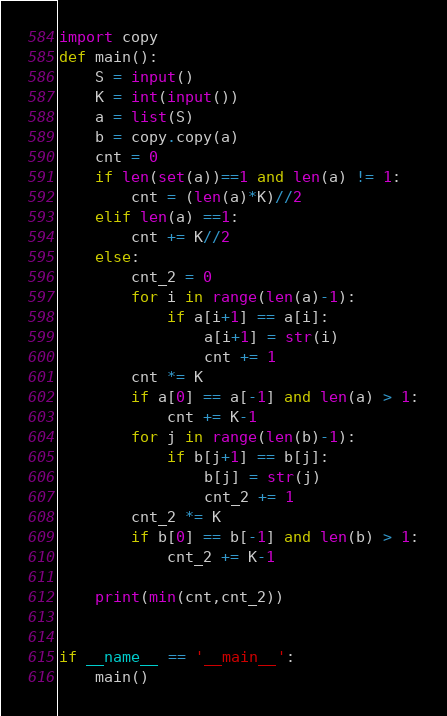Convert code to text. <code><loc_0><loc_0><loc_500><loc_500><_Python_>import copy
def main():
    S = input()
    K = int(input())
    a = list(S)
    b = copy.copy(a)
    cnt = 0
    if len(set(a))==1 and len(a) != 1:
        cnt = (len(a)*K)//2
    elif len(a) ==1:
        cnt += K//2
    else:
        cnt_2 = 0
        for i in range(len(a)-1):
            if a[i+1] == a[i]:
                a[i+1] = str(i)
                cnt += 1
        cnt *= K
        if a[0] == a[-1] and len(a) > 1:
            cnt += K-1
        for j in range(len(b)-1):
            if b[j+1] == b[j]:
                b[j] = str(j)
                cnt_2 += 1
        cnt_2 *= K
        if b[0] == b[-1] and len(b) > 1:
            cnt_2 += K-1

    print(min(cnt,cnt_2))

    
if __name__ == '__main__':
    main()</code> 